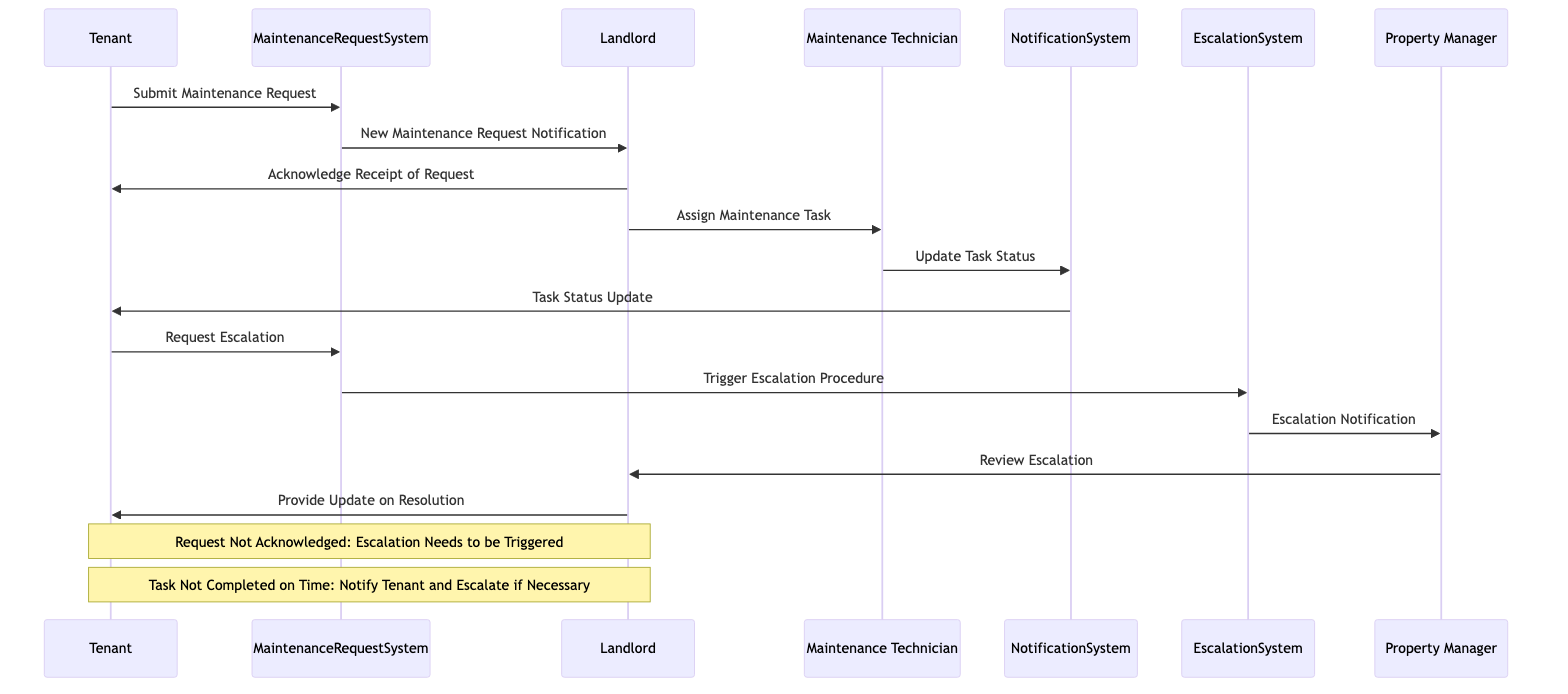What actor initiates the maintenance request? The diagram shows the interaction starting from the Tenant, who submits the maintenance request to the Maintenance Request System.
Answer: Tenant How many messages are exchanged between the Tenant and the Landlord? There are two messages exchanged: one is the acknowledgment of the request from the Landlord to the Tenant, and the other is an update from the Landlord on the resolution.
Answer: Two What system does the Tenant use to submit the maintenance request? The Tenant submits the maintenance request through the Maintenance Request System, as indicated in the first message of the diagram.
Answer: Maintenance Request System Who receives the escalation notification? The escalation notification is sent to the Property Manager from the Escalation System as part of the escalation process detailed in the sequence of messages.
Answer: Property Manager What happens if the maintenance request is not acknowledged by the Landlord? The diagram includes a condition stating that if the request is not acknowledged, an escalation needs to be triggered, indicating that the Tenant must take further action.
Answer: Escalation Needs to be Triggered Which actor performs the repair work? The Maintenance Technician is designated to perform the repair work after being assigned by the Landlord, as shown in the sequence of messages.
Answer: Maintenance Technician What action does the Maintenance Technician take to update the task status? The Maintenance Technician communicates with the Notification System to update the status of the task, which is reflected in the flow of messages.
Answer: Update Task Status What occurs when the task is not completed on time? The diagram specifies that when the task is not completed on time, the Landlord needs to notify the Tenant and escalate if necessary, indicating a follow-up action is required.
Answer: Notify Tenant and Escalate if Necessary How does the escalation procedure get triggered? The escalation procedure is triggered when the Tenant requests escalation through the Maintenance Request System, leading to a transition to the Escalation System.
Answer: Trigger Escalation Procedure 